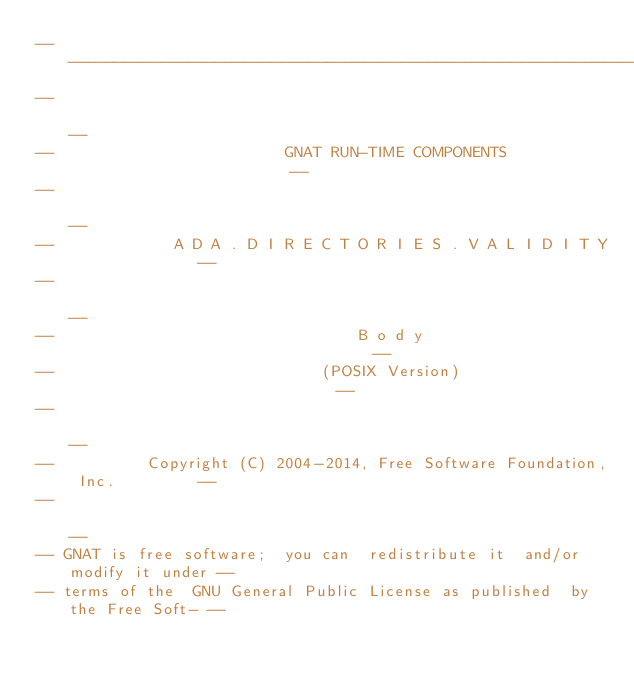<code> <loc_0><loc_0><loc_500><loc_500><_Ada_>------------------------------------------------------------------------------
--                                                                          --
--                         GNAT RUN-TIME COMPONENTS                         --
--                                                                          --
--             A D A . D I R E C T O R I E S . V A L I D I T Y              --
--                                                                          --
--                                 B o d y                                  --
--                             (POSIX Version)                              --
--                                                                          --
--          Copyright (C) 2004-2014, Free Software Foundation, Inc.         --
--                                                                          --
-- GNAT is free software;  you can  redistribute it  and/or modify it under --
-- terms of the  GNU General Public License as published  by the Free Soft- --</code> 